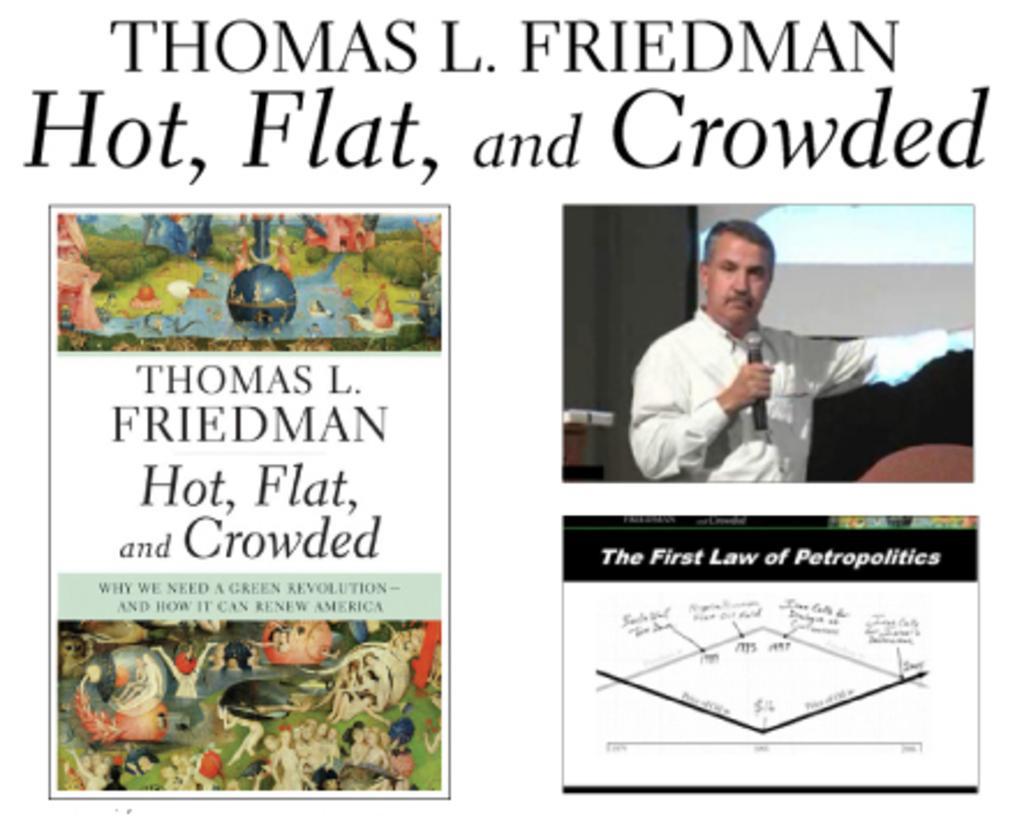How would you summarize this image in a sentence or two? In this image I can see the person standing and holding the microphone and I can see few cartoon pictures and I can also see something is written on the image. 